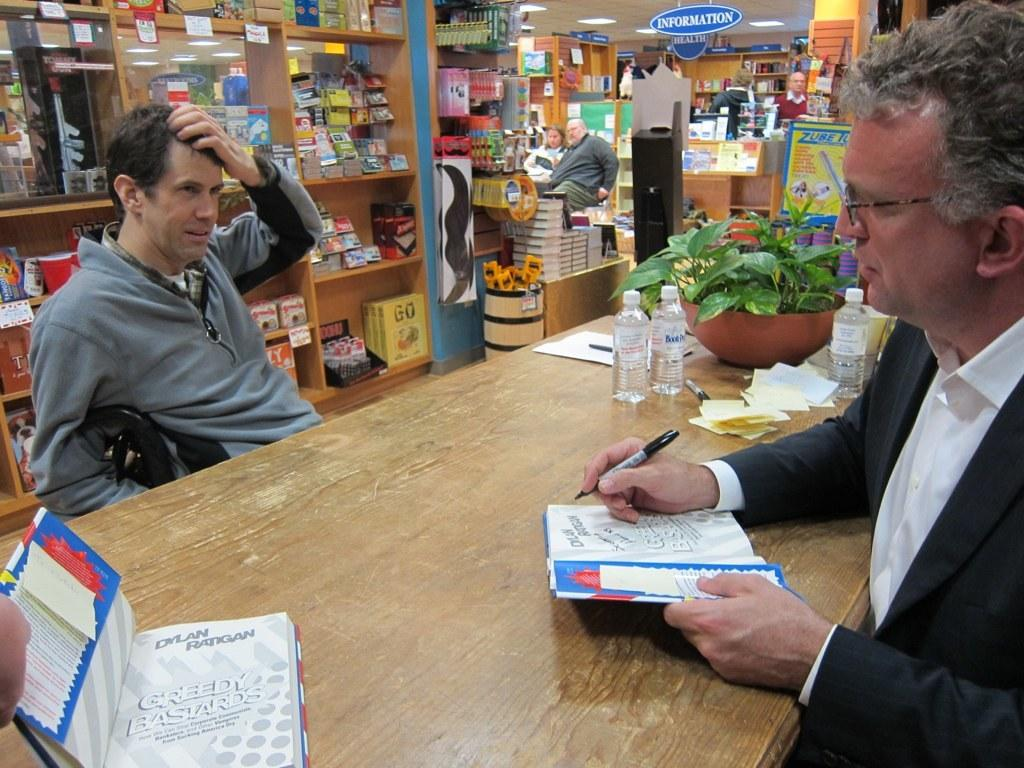<image>
Summarize the visual content of the image. A man writing in a notebook across from a man holding his head and a sign saying information behind them. 